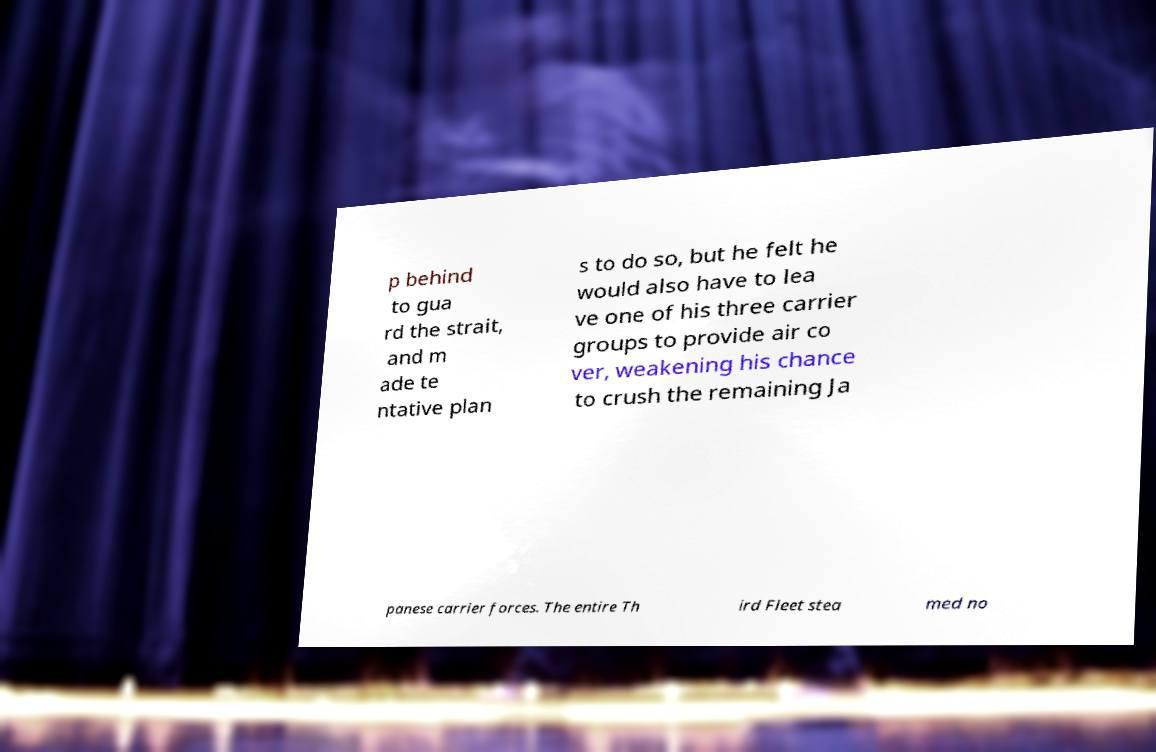Please read and relay the text visible in this image. What does it say? p behind to gua rd the strait, and m ade te ntative plan s to do so, but he felt he would also have to lea ve one of his three carrier groups to provide air co ver, weakening his chance to crush the remaining Ja panese carrier forces. The entire Th ird Fleet stea med no 